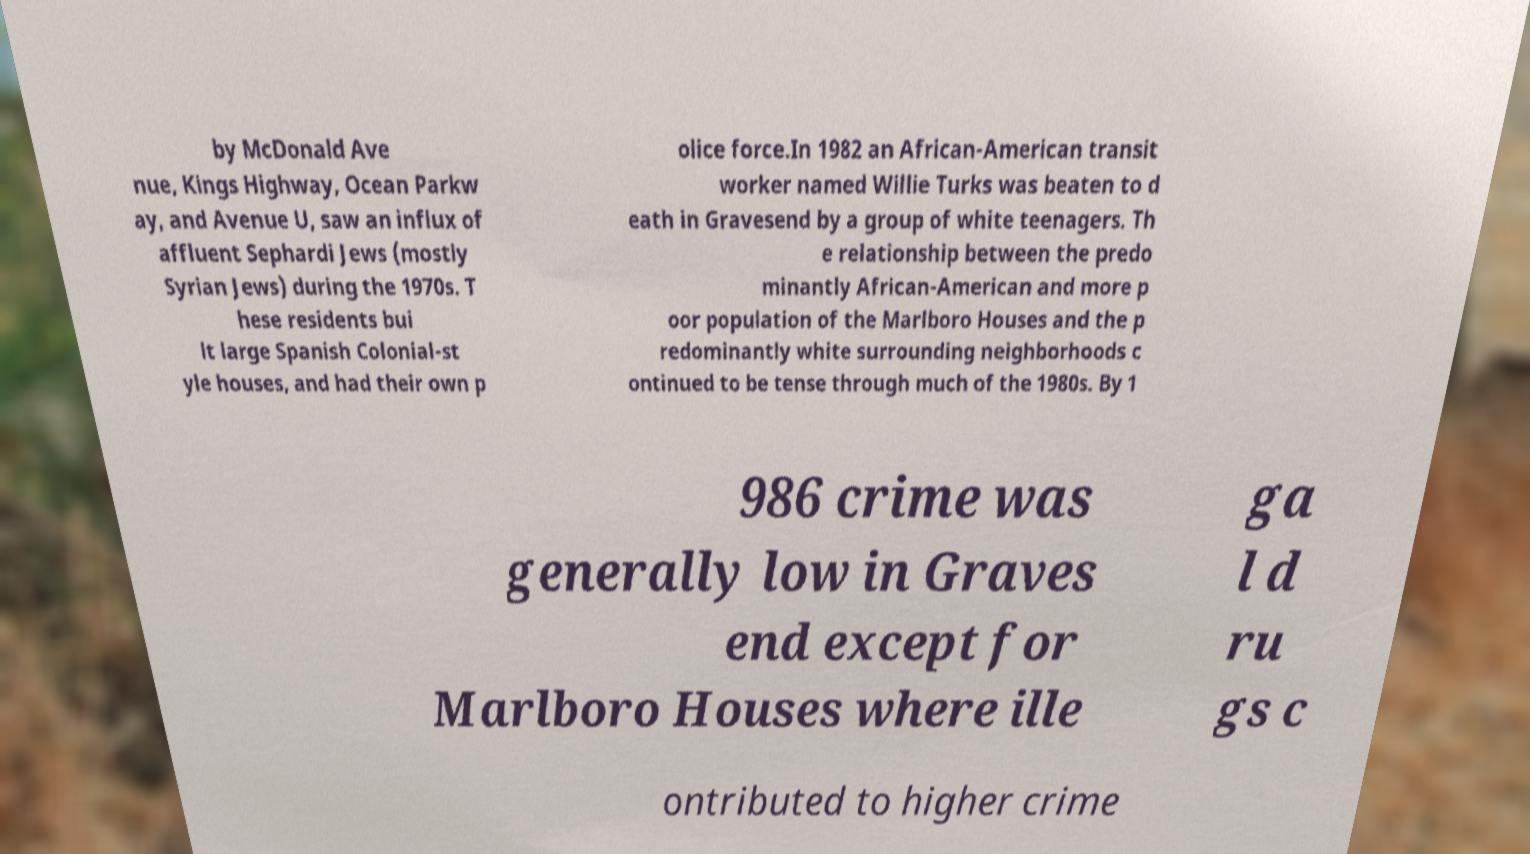What messages or text are displayed in this image? I need them in a readable, typed format. by McDonald Ave nue, Kings Highway, Ocean Parkw ay, and Avenue U, saw an influx of affluent Sephardi Jews (mostly Syrian Jews) during the 1970s. T hese residents bui lt large Spanish Colonial-st yle houses, and had their own p olice force.In 1982 an African-American transit worker named Willie Turks was beaten to d eath in Gravesend by a group of white teenagers. Th e relationship between the predo minantly African-American and more p oor population of the Marlboro Houses and the p redominantly white surrounding neighborhoods c ontinued to be tense through much of the 1980s. By 1 986 crime was generally low in Graves end except for Marlboro Houses where ille ga l d ru gs c ontributed to higher crime 